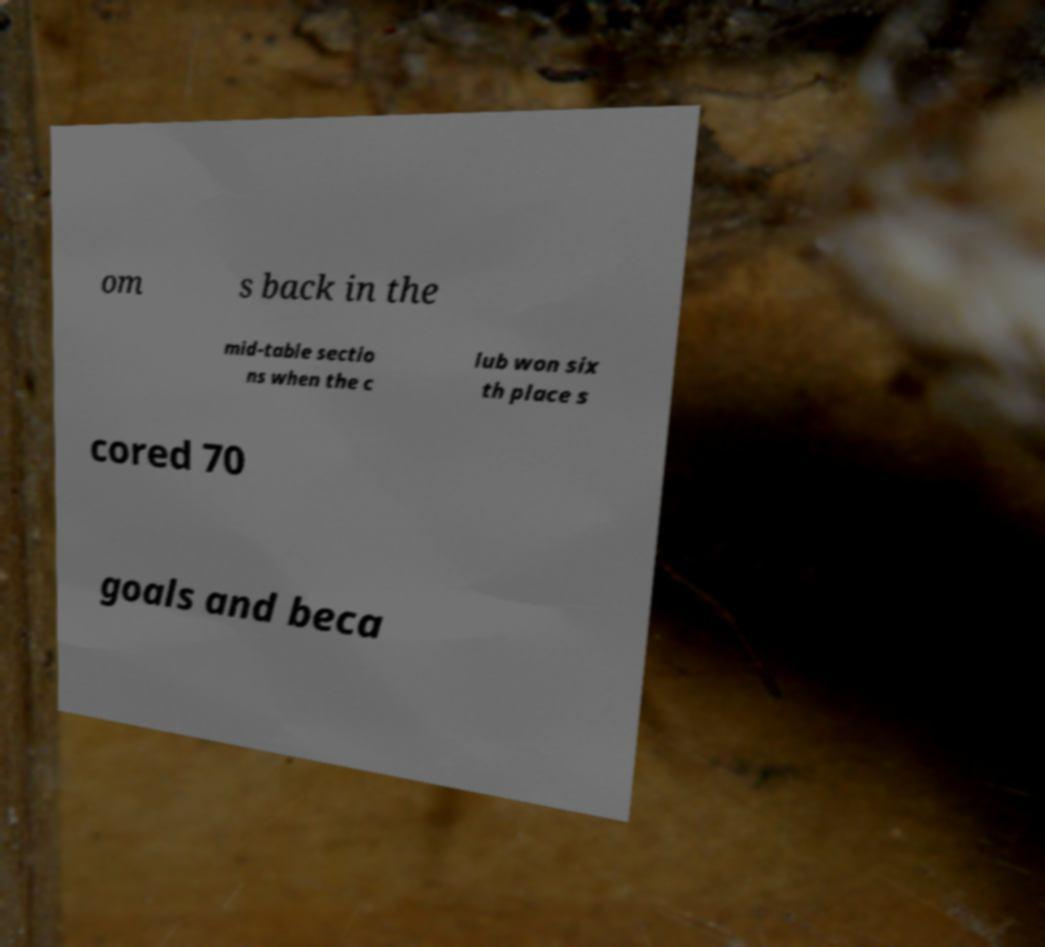Could you extract and type out the text from this image? om s back in the mid-table sectio ns when the c lub won six th place s cored 70 goals and beca 